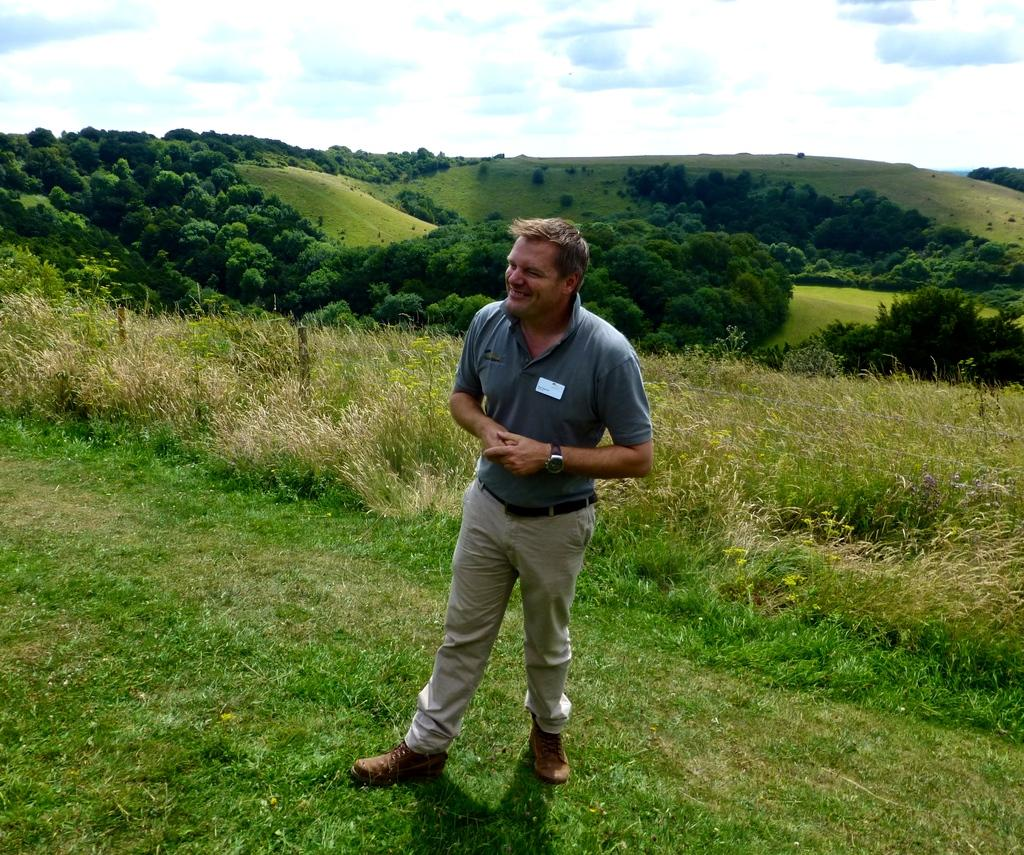What is the main subject of the image? There is a man standing in the image. Where is the man standing? The man is standing on the ground. What can be seen in the background of the image? There are grasslands in the background of the image, and trees are present in the grasslands. What type of vegetation is visible at the bottom of the image? There is grass at the bottom of the image. What type of hair can be seen on the man's head in the image? There is no user in the image, and the man's hair cannot be seen in the provided facts. 